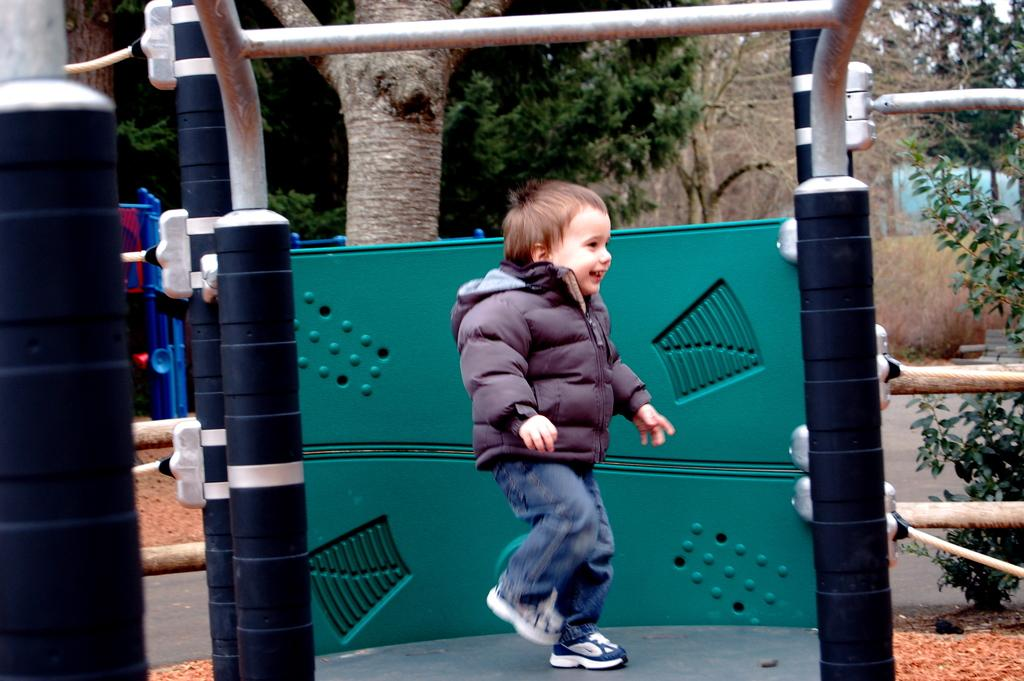What is the main subject of the picture? The main subject of the picture is a kid. What is the kid wearing in the picture? The kid is wearing a black jacket. What is the kid's posture in the picture? The kid is standing. What can be seen in the background of the picture? There are trees in the background of the picture. What type of grain is being served on the sofa in the image? There is no sofa or grain present in the image; it features a kid wearing a black jacket and standing in front of trees. 